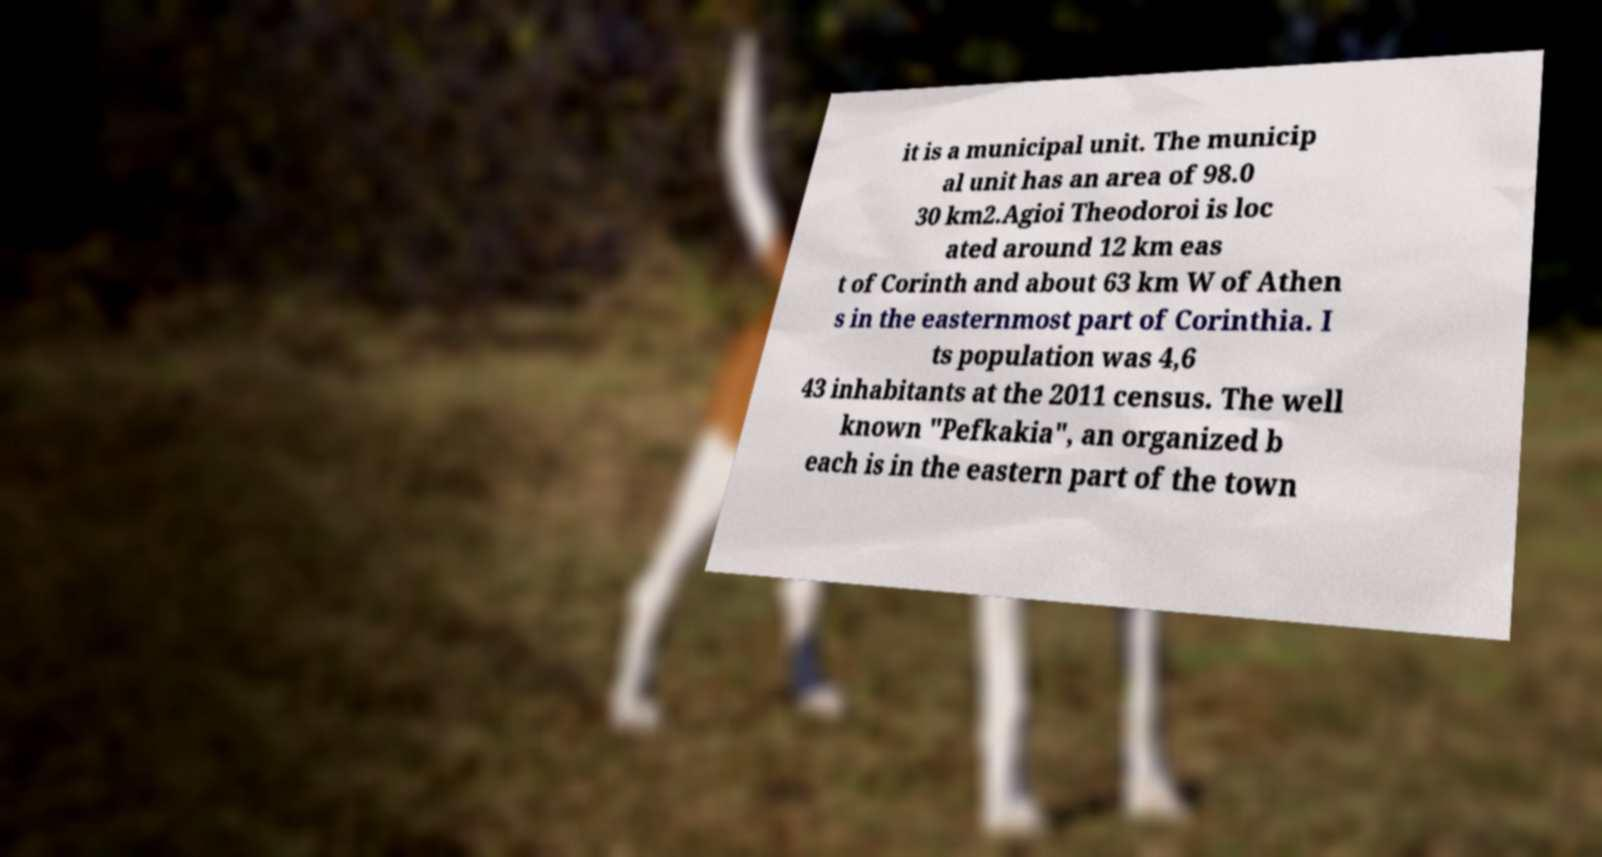Could you assist in decoding the text presented in this image and type it out clearly? it is a municipal unit. The municip al unit has an area of 98.0 30 km2.Agioi Theodoroi is loc ated around 12 km eas t of Corinth and about 63 km W of Athen s in the easternmost part of Corinthia. I ts population was 4,6 43 inhabitants at the 2011 census. The well known "Pefkakia", an organized b each is in the eastern part of the town 